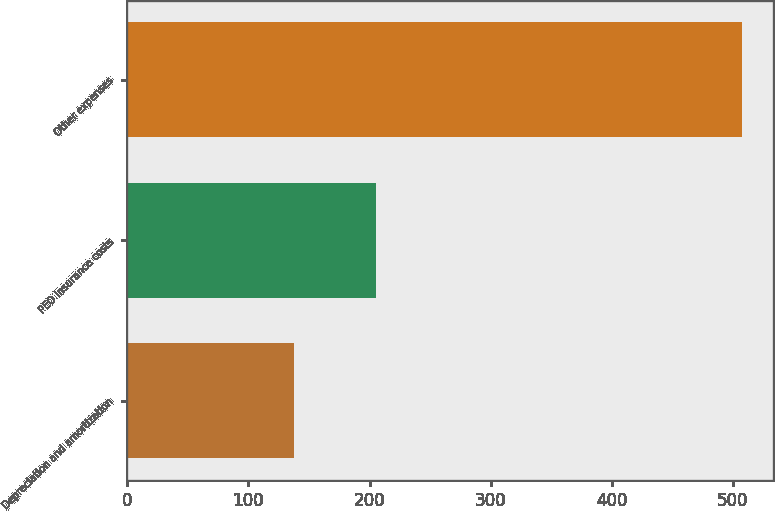Convert chart to OTSL. <chart><loc_0><loc_0><loc_500><loc_500><bar_chart><fcel>Depreciation and amortization<fcel>PEO insurance costs<fcel>Other expenses<nl><fcel>138<fcel>205.2<fcel>507.8<nl></chart> 